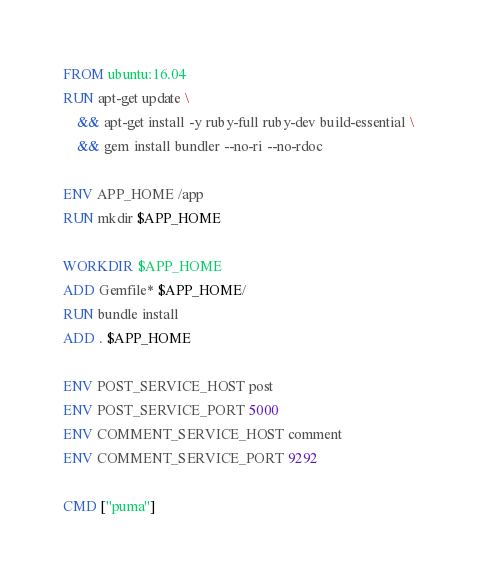Convert code to text. <code><loc_0><loc_0><loc_500><loc_500><_Dockerfile_>FROM ubuntu:16.04
RUN apt-get update \
    && apt-get install -y ruby-full ruby-dev build-essential \
    && gem install bundler --no-ri --no-rdoc

ENV APP_HOME /app
RUN mkdir $APP_HOME

WORKDIR $APP_HOME
ADD Gemfile* $APP_HOME/
RUN bundle install
ADD . $APP_HOME

ENV POST_SERVICE_HOST post
ENV POST_SERVICE_PORT 5000
ENV COMMENT_SERVICE_HOST comment
ENV COMMENT_SERVICE_PORT 9292

CMD ["puma"]</code> 